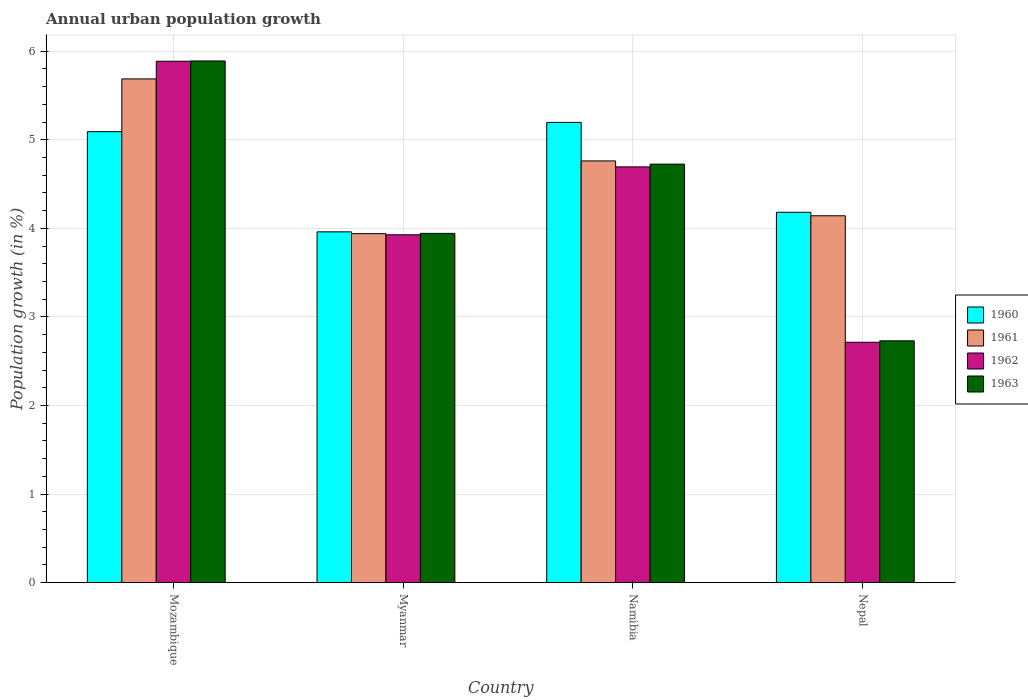How many different coloured bars are there?
Your answer should be very brief. 4. How many groups of bars are there?
Your response must be concise. 4. Are the number of bars on each tick of the X-axis equal?
Your answer should be compact. Yes. How many bars are there on the 2nd tick from the right?
Give a very brief answer. 4. What is the label of the 4th group of bars from the left?
Your response must be concise. Nepal. In how many cases, is the number of bars for a given country not equal to the number of legend labels?
Provide a succinct answer. 0. What is the percentage of urban population growth in 1960 in Nepal?
Provide a succinct answer. 4.18. Across all countries, what is the maximum percentage of urban population growth in 1962?
Make the answer very short. 5.89. Across all countries, what is the minimum percentage of urban population growth in 1961?
Keep it short and to the point. 3.94. In which country was the percentage of urban population growth in 1963 maximum?
Offer a terse response. Mozambique. In which country was the percentage of urban population growth in 1962 minimum?
Your answer should be very brief. Nepal. What is the total percentage of urban population growth in 1963 in the graph?
Provide a succinct answer. 17.29. What is the difference between the percentage of urban population growth in 1960 in Mozambique and that in Nepal?
Your response must be concise. 0.91. What is the difference between the percentage of urban population growth in 1961 in Namibia and the percentage of urban population growth in 1963 in Myanmar?
Your answer should be very brief. 0.82. What is the average percentage of urban population growth in 1960 per country?
Your answer should be very brief. 4.61. What is the difference between the percentage of urban population growth of/in 1960 and percentage of urban population growth of/in 1961 in Namibia?
Offer a terse response. 0.44. In how many countries, is the percentage of urban population growth in 1961 greater than 1.8 %?
Provide a short and direct response. 4. What is the ratio of the percentage of urban population growth in 1962 in Mozambique to that in Nepal?
Keep it short and to the point. 2.17. Is the difference between the percentage of urban population growth in 1960 in Mozambique and Nepal greater than the difference between the percentage of urban population growth in 1961 in Mozambique and Nepal?
Offer a very short reply. No. What is the difference between the highest and the second highest percentage of urban population growth in 1960?
Keep it short and to the point. 0.91. What is the difference between the highest and the lowest percentage of urban population growth in 1962?
Your response must be concise. 3.17. In how many countries, is the percentage of urban population growth in 1963 greater than the average percentage of urban population growth in 1963 taken over all countries?
Your response must be concise. 2. Is it the case that in every country, the sum of the percentage of urban population growth in 1960 and percentage of urban population growth in 1961 is greater than the sum of percentage of urban population growth in 1963 and percentage of urban population growth in 1962?
Provide a short and direct response. No. What does the 3rd bar from the left in Namibia represents?
Provide a short and direct response. 1962. What does the 1st bar from the right in Mozambique represents?
Your answer should be very brief. 1963. How many countries are there in the graph?
Offer a very short reply. 4. What is the difference between two consecutive major ticks on the Y-axis?
Provide a short and direct response. 1. Are the values on the major ticks of Y-axis written in scientific E-notation?
Keep it short and to the point. No. Does the graph contain grids?
Offer a terse response. Yes. Where does the legend appear in the graph?
Give a very brief answer. Center right. How many legend labels are there?
Your response must be concise. 4. How are the legend labels stacked?
Offer a very short reply. Vertical. What is the title of the graph?
Offer a very short reply. Annual urban population growth. Does "1984" appear as one of the legend labels in the graph?
Offer a very short reply. No. What is the label or title of the X-axis?
Offer a very short reply. Country. What is the label or title of the Y-axis?
Your response must be concise. Population growth (in %). What is the Population growth (in %) in 1960 in Mozambique?
Keep it short and to the point. 5.09. What is the Population growth (in %) in 1961 in Mozambique?
Offer a terse response. 5.69. What is the Population growth (in %) of 1962 in Mozambique?
Your answer should be very brief. 5.89. What is the Population growth (in %) in 1963 in Mozambique?
Provide a short and direct response. 5.89. What is the Population growth (in %) of 1960 in Myanmar?
Your response must be concise. 3.96. What is the Population growth (in %) of 1961 in Myanmar?
Give a very brief answer. 3.94. What is the Population growth (in %) of 1962 in Myanmar?
Ensure brevity in your answer.  3.93. What is the Population growth (in %) of 1963 in Myanmar?
Your answer should be compact. 3.94. What is the Population growth (in %) of 1960 in Namibia?
Your answer should be compact. 5.2. What is the Population growth (in %) of 1961 in Namibia?
Your answer should be compact. 4.76. What is the Population growth (in %) in 1962 in Namibia?
Make the answer very short. 4.69. What is the Population growth (in %) of 1963 in Namibia?
Offer a very short reply. 4.73. What is the Population growth (in %) in 1960 in Nepal?
Provide a short and direct response. 4.18. What is the Population growth (in %) of 1961 in Nepal?
Offer a very short reply. 4.14. What is the Population growth (in %) of 1962 in Nepal?
Ensure brevity in your answer.  2.71. What is the Population growth (in %) of 1963 in Nepal?
Provide a succinct answer. 2.73. Across all countries, what is the maximum Population growth (in %) in 1960?
Make the answer very short. 5.2. Across all countries, what is the maximum Population growth (in %) in 1961?
Make the answer very short. 5.69. Across all countries, what is the maximum Population growth (in %) of 1962?
Your answer should be very brief. 5.89. Across all countries, what is the maximum Population growth (in %) in 1963?
Provide a short and direct response. 5.89. Across all countries, what is the minimum Population growth (in %) in 1960?
Offer a terse response. 3.96. Across all countries, what is the minimum Population growth (in %) in 1961?
Give a very brief answer. 3.94. Across all countries, what is the minimum Population growth (in %) of 1962?
Keep it short and to the point. 2.71. Across all countries, what is the minimum Population growth (in %) of 1963?
Make the answer very short. 2.73. What is the total Population growth (in %) in 1960 in the graph?
Offer a terse response. 18.43. What is the total Population growth (in %) in 1961 in the graph?
Your answer should be compact. 18.53. What is the total Population growth (in %) in 1962 in the graph?
Your answer should be very brief. 17.22. What is the total Population growth (in %) in 1963 in the graph?
Your answer should be very brief. 17.29. What is the difference between the Population growth (in %) in 1960 in Mozambique and that in Myanmar?
Keep it short and to the point. 1.13. What is the difference between the Population growth (in %) in 1961 in Mozambique and that in Myanmar?
Make the answer very short. 1.75. What is the difference between the Population growth (in %) in 1962 in Mozambique and that in Myanmar?
Provide a short and direct response. 1.96. What is the difference between the Population growth (in %) in 1963 in Mozambique and that in Myanmar?
Your answer should be compact. 1.95. What is the difference between the Population growth (in %) in 1960 in Mozambique and that in Namibia?
Provide a succinct answer. -0.1. What is the difference between the Population growth (in %) of 1961 in Mozambique and that in Namibia?
Your response must be concise. 0.93. What is the difference between the Population growth (in %) in 1962 in Mozambique and that in Namibia?
Make the answer very short. 1.19. What is the difference between the Population growth (in %) in 1963 in Mozambique and that in Namibia?
Your answer should be compact. 1.16. What is the difference between the Population growth (in %) of 1960 in Mozambique and that in Nepal?
Offer a terse response. 0.91. What is the difference between the Population growth (in %) of 1961 in Mozambique and that in Nepal?
Offer a terse response. 1.54. What is the difference between the Population growth (in %) in 1962 in Mozambique and that in Nepal?
Give a very brief answer. 3.17. What is the difference between the Population growth (in %) of 1963 in Mozambique and that in Nepal?
Give a very brief answer. 3.16. What is the difference between the Population growth (in %) in 1960 in Myanmar and that in Namibia?
Ensure brevity in your answer.  -1.24. What is the difference between the Population growth (in %) of 1961 in Myanmar and that in Namibia?
Keep it short and to the point. -0.82. What is the difference between the Population growth (in %) in 1962 in Myanmar and that in Namibia?
Your response must be concise. -0.77. What is the difference between the Population growth (in %) of 1963 in Myanmar and that in Namibia?
Provide a succinct answer. -0.78. What is the difference between the Population growth (in %) of 1960 in Myanmar and that in Nepal?
Make the answer very short. -0.22. What is the difference between the Population growth (in %) of 1961 in Myanmar and that in Nepal?
Keep it short and to the point. -0.2. What is the difference between the Population growth (in %) of 1962 in Myanmar and that in Nepal?
Give a very brief answer. 1.21. What is the difference between the Population growth (in %) in 1963 in Myanmar and that in Nepal?
Give a very brief answer. 1.21. What is the difference between the Population growth (in %) in 1960 in Namibia and that in Nepal?
Provide a short and direct response. 1.01. What is the difference between the Population growth (in %) in 1961 in Namibia and that in Nepal?
Ensure brevity in your answer.  0.62. What is the difference between the Population growth (in %) in 1962 in Namibia and that in Nepal?
Make the answer very short. 1.98. What is the difference between the Population growth (in %) in 1963 in Namibia and that in Nepal?
Offer a very short reply. 1.99. What is the difference between the Population growth (in %) in 1960 in Mozambique and the Population growth (in %) in 1961 in Myanmar?
Make the answer very short. 1.15. What is the difference between the Population growth (in %) in 1960 in Mozambique and the Population growth (in %) in 1962 in Myanmar?
Keep it short and to the point. 1.16. What is the difference between the Population growth (in %) of 1960 in Mozambique and the Population growth (in %) of 1963 in Myanmar?
Ensure brevity in your answer.  1.15. What is the difference between the Population growth (in %) of 1961 in Mozambique and the Population growth (in %) of 1962 in Myanmar?
Keep it short and to the point. 1.76. What is the difference between the Population growth (in %) in 1961 in Mozambique and the Population growth (in %) in 1963 in Myanmar?
Keep it short and to the point. 1.74. What is the difference between the Population growth (in %) in 1962 in Mozambique and the Population growth (in %) in 1963 in Myanmar?
Offer a terse response. 1.94. What is the difference between the Population growth (in %) of 1960 in Mozambique and the Population growth (in %) of 1961 in Namibia?
Your answer should be very brief. 0.33. What is the difference between the Population growth (in %) in 1960 in Mozambique and the Population growth (in %) in 1962 in Namibia?
Keep it short and to the point. 0.4. What is the difference between the Population growth (in %) in 1960 in Mozambique and the Population growth (in %) in 1963 in Namibia?
Give a very brief answer. 0.37. What is the difference between the Population growth (in %) of 1961 in Mozambique and the Population growth (in %) of 1963 in Namibia?
Offer a very short reply. 0.96. What is the difference between the Population growth (in %) of 1962 in Mozambique and the Population growth (in %) of 1963 in Namibia?
Your answer should be very brief. 1.16. What is the difference between the Population growth (in %) in 1960 in Mozambique and the Population growth (in %) in 1961 in Nepal?
Keep it short and to the point. 0.95. What is the difference between the Population growth (in %) in 1960 in Mozambique and the Population growth (in %) in 1962 in Nepal?
Ensure brevity in your answer.  2.38. What is the difference between the Population growth (in %) in 1960 in Mozambique and the Population growth (in %) in 1963 in Nepal?
Your answer should be very brief. 2.36. What is the difference between the Population growth (in %) of 1961 in Mozambique and the Population growth (in %) of 1962 in Nepal?
Provide a short and direct response. 2.97. What is the difference between the Population growth (in %) in 1961 in Mozambique and the Population growth (in %) in 1963 in Nepal?
Your answer should be compact. 2.96. What is the difference between the Population growth (in %) in 1962 in Mozambique and the Population growth (in %) in 1963 in Nepal?
Ensure brevity in your answer.  3.16. What is the difference between the Population growth (in %) in 1960 in Myanmar and the Population growth (in %) in 1961 in Namibia?
Give a very brief answer. -0.8. What is the difference between the Population growth (in %) of 1960 in Myanmar and the Population growth (in %) of 1962 in Namibia?
Your response must be concise. -0.73. What is the difference between the Population growth (in %) in 1960 in Myanmar and the Population growth (in %) in 1963 in Namibia?
Your response must be concise. -0.76. What is the difference between the Population growth (in %) of 1961 in Myanmar and the Population growth (in %) of 1962 in Namibia?
Ensure brevity in your answer.  -0.75. What is the difference between the Population growth (in %) in 1961 in Myanmar and the Population growth (in %) in 1963 in Namibia?
Your response must be concise. -0.78. What is the difference between the Population growth (in %) in 1962 in Myanmar and the Population growth (in %) in 1963 in Namibia?
Keep it short and to the point. -0.8. What is the difference between the Population growth (in %) in 1960 in Myanmar and the Population growth (in %) in 1961 in Nepal?
Offer a very short reply. -0.18. What is the difference between the Population growth (in %) in 1960 in Myanmar and the Population growth (in %) in 1962 in Nepal?
Make the answer very short. 1.25. What is the difference between the Population growth (in %) of 1960 in Myanmar and the Population growth (in %) of 1963 in Nepal?
Ensure brevity in your answer.  1.23. What is the difference between the Population growth (in %) in 1961 in Myanmar and the Population growth (in %) in 1962 in Nepal?
Make the answer very short. 1.23. What is the difference between the Population growth (in %) of 1961 in Myanmar and the Population growth (in %) of 1963 in Nepal?
Ensure brevity in your answer.  1.21. What is the difference between the Population growth (in %) in 1962 in Myanmar and the Population growth (in %) in 1963 in Nepal?
Offer a terse response. 1.2. What is the difference between the Population growth (in %) in 1960 in Namibia and the Population growth (in %) in 1961 in Nepal?
Give a very brief answer. 1.05. What is the difference between the Population growth (in %) of 1960 in Namibia and the Population growth (in %) of 1962 in Nepal?
Offer a terse response. 2.48. What is the difference between the Population growth (in %) of 1960 in Namibia and the Population growth (in %) of 1963 in Nepal?
Offer a very short reply. 2.47. What is the difference between the Population growth (in %) of 1961 in Namibia and the Population growth (in %) of 1962 in Nepal?
Keep it short and to the point. 2.05. What is the difference between the Population growth (in %) of 1961 in Namibia and the Population growth (in %) of 1963 in Nepal?
Offer a very short reply. 2.03. What is the difference between the Population growth (in %) of 1962 in Namibia and the Population growth (in %) of 1963 in Nepal?
Offer a terse response. 1.96. What is the average Population growth (in %) in 1960 per country?
Provide a succinct answer. 4.61. What is the average Population growth (in %) in 1961 per country?
Provide a short and direct response. 4.63. What is the average Population growth (in %) of 1962 per country?
Your answer should be very brief. 4.31. What is the average Population growth (in %) in 1963 per country?
Offer a terse response. 4.32. What is the difference between the Population growth (in %) in 1960 and Population growth (in %) in 1961 in Mozambique?
Offer a terse response. -0.6. What is the difference between the Population growth (in %) in 1960 and Population growth (in %) in 1962 in Mozambique?
Your response must be concise. -0.79. What is the difference between the Population growth (in %) in 1960 and Population growth (in %) in 1963 in Mozambique?
Your response must be concise. -0.8. What is the difference between the Population growth (in %) of 1961 and Population growth (in %) of 1962 in Mozambique?
Your response must be concise. -0.2. What is the difference between the Population growth (in %) in 1961 and Population growth (in %) in 1963 in Mozambique?
Give a very brief answer. -0.2. What is the difference between the Population growth (in %) in 1962 and Population growth (in %) in 1963 in Mozambique?
Provide a succinct answer. -0. What is the difference between the Population growth (in %) in 1960 and Population growth (in %) in 1961 in Myanmar?
Ensure brevity in your answer.  0.02. What is the difference between the Population growth (in %) of 1960 and Population growth (in %) of 1962 in Myanmar?
Make the answer very short. 0.03. What is the difference between the Population growth (in %) in 1960 and Population growth (in %) in 1963 in Myanmar?
Make the answer very short. 0.02. What is the difference between the Population growth (in %) of 1961 and Population growth (in %) of 1962 in Myanmar?
Offer a terse response. 0.01. What is the difference between the Population growth (in %) in 1961 and Population growth (in %) in 1963 in Myanmar?
Keep it short and to the point. -0. What is the difference between the Population growth (in %) in 1962 and Population growth (in %) in 1963 in Myanmar?
Make the answer very short. -0.02. What is the difference between the Population growth (in %) in 1960 and Population growth (in %) in 1961 in Namibia?
Your answer should be very brief. 0.43. What is the difference between the Population growth (in %) of 1960 and Population growth (in %) of 1962 in Namibia?
Offer a very short reply. 0.5. What is the difference between the Population growth (in %) of 1960 and Population growth (in %) of 1963 in Namibia?
Your answer should be compact. 0.47. What is the difference between the Population growth (in %) of 1961 and Population growth (in %) of 1962 in Namibia?
Provide a short and direct response. 0.07. What is the difference between the Population growth (in %) in 1961 and Population growth (in %) in 1963 in Namibia?
Your answer should be very brief. 0.04. What is the difference between the Population growth (in %) of 1962 and Population growth (in %) of 1963 in Namibia?
Provide a short and direct response. -0.03. What is the difference between the Population growth (in %) in 1960 and Population growth (in %) in 1961 in Nepal?
Give a very brief answer. 0.04. What is the difference between the Population growth (in %) in 1960 and Population growth (in %) in 1962 in Nepal?
Offer a terse response. 1.47. What is the difference between the Population growth (in %) in 1960 and Population growth (in %) in 1963 in Nepal?
Offer a terse response. 1.45. What is the difference between the Population growth (in %) of 1961 and Population growth (in %) of 1962 in Nepal?
Keep it short and to the point. 1.43. What is the difference between the Population growth (in %) of 1961 and Population growth (in %) of 1963 in Nepal?
Ensure brevity in your answer.  1.41. What is the difference between the Population growth (in %) of 1962 and Population growth (in %) of 1963 in Nepal?
Offer a terse response. -0.02. What is the ratio of the Population growth (in %) of 1960 in Mozambique to that in Myanmar?
Give a very brief answer. 1.29. What is the ratio of the Population growth (in %) of 1961 in Mozambique to that in Myanmar?
Offer a very short reply. 1.44. What is the ratio of the Population growth (in %) of 1962 in Mozambique to that in Myanmar?
Offer a terse response. 1.5. What is the ratio of the Population growth (in %) in 1963 in Mozambique to that in Myanmar?
Offer a terse response. 1.49. What is the ratio of the Population growth (in %) in 1960 in Mozambique to that in Namibia?
Offer a very short reply. 0.98. What is the ratio of the Population growth (in %) in 1961 in Mozambique to that in Namibia?
Offer a very short reply. 1.19. What is the ratio of the Population growth (in %) of 1962 in Mozambique to that in Namibia?
Keep it short and to the point. 1.25. What is the ratio of the Population growth (in %) of 1963 in Mozambique to that in Namibia?
Your response must be concise. 1.25. What is the ratio of the Population growth (in %) in 1960 in Mozambique to that in Nepal?
Offer a terse response. 1.22. What is the ratio of the Population growth (in %) of 1961 in Mozambique to that in Nepal?
Provide a short and direct response. 1.37. What is the ratio of the Population growth (in %) in 1962 in Mozambique to that in Nepal?
Your response must be concise. 2.17. What is the ratio of the Population growth (in %) of 1963 in Mozambique to that in Nepal?
Ensure brevity in your answer.  2.16. What is the ratio of the Population growth (in %) in 1960 in Myanmar to that in Namibia?
Ensure brevity in your answer.  0.76. What is the ratio of the Population growth (in %) in 1961 in Myanmar to that in Namibia?
Make the answer very short. 0.83. What is the ratio of the Population growth (in %) of 1962 in Myanmar to that in Namibia?
Ensure brevity in your answer.  0.84. What is the ratio of the Population growth (in %) of 1963 in Myanmar to that in Namibia?
Your answer should be compact. 0.83. What is the ratio of the Population growth (in %) in 1960 in Myanmar to that in Nepal?
Ensure brevity in your answer.  0.95. What is the ratio of the Population growth (in %) in 1961 in Myanmar to that in Nepal?
Make the answer very short. 0.95. What is the ratio of the Population growth (in %) in 1962 in Myanmar to that in Nepal?
Ensure brevity in your answer.  1.45. What is the ratio of the Population growth (in %) in 1963 in Myanmar to that in Nepal?
Your answer should be compact. 1.44. What is the ratio of the Population growth (in %) in 1960 in Namibia to that in Nepal?
Offer a very short reply. 1.24. What is the ratio of the Population growth (in %) of 1961 in Namibia to that in Nepal?
Offer a terse response. 1.15. What is the ratio of the Population growth (in %) in 1962 in Namibia to that in Nepal?
Make the answer very short. 1.73. What is the ratio of the Population growth (in %) of 1963 in Namibia to that in Nepal?
Your response must be concise. 1.73. What is the difference between the highest and the second highest Population growth (in %) in 1960?
Your response must be concise. 0.1. What is the difference between the highest and the second highest Population growth (in %) of 1961?
Provide a succinct answer. 0.93. What is the difference between the highest and the second highest Population growth (in %) of 1962?
Make the answer very short. 1.19. What is the difference between the highest and the second highest Population growth (in %) of 1963?
Make the answer very short. 1.16. What is the difference between the highest and the lowest Population growth (in %) in 1960?
Your answer should be very brief. 1.24. What is the difference between the highest and the lowest Population growth (in %) in 1961?
Provide a short and direct response. 1.75. What is the difference between the highest and the lowest Population growth (in %) of 1962?
Provide a short and direct response. 3.17. What is the difference between the highest and the lowest Population growth (in %) in 1963?
Ensure brevity in your answer.  3.16. 